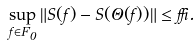Convert formula to latex. <formula><loc_0><loc_0><loc_500><loc_500>\sup _ { f \in F _ { 0 } } \| S ( f ) - S ( \Theta ( f ) ) \| \leq \delta .</formula> 